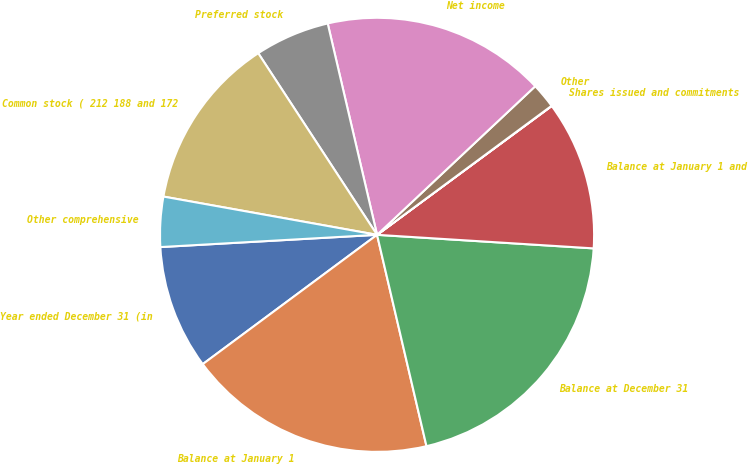Convert chart. <chart><loc_0><loc_0><loc_500><loc_500><pie_chart><fcel>Year ended December 31 (in<fcel>Balance at January 1<fcel>Balance at December 31<fcel>Balance at January 1 and<fcel>Shares issued and commitments<fcel>Other<fcel>Net income<fcel>Preferred stock<fcel>Common stock ( 212 188 and 172<fcel>Other comprehensive<nl><fcel>9.26%<fcel>18.5%<fcel>20.35%<fcel>11.11%<fcel>0.02%<fcel>1.87%<fcel>16.65%<fcel>5.57%<fcel>12.96%<fcel>3.72%<nl></chart> 